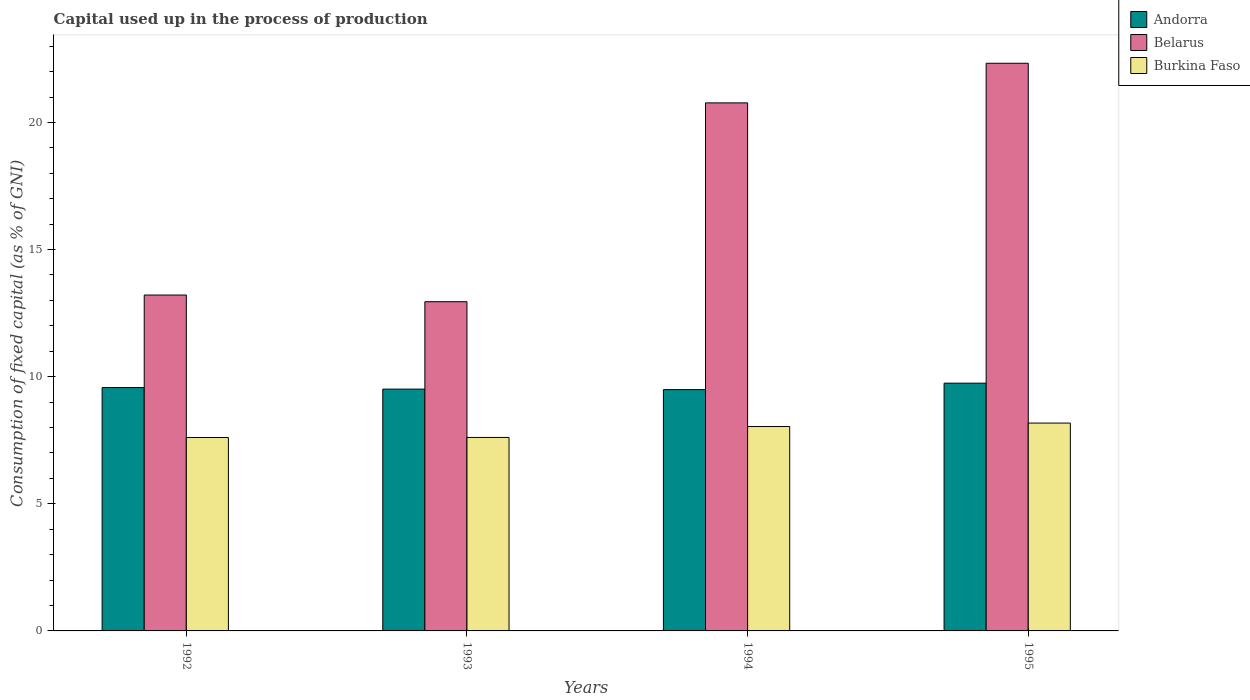Are the number of bars per tick equal to the number of legend labels?
Provide a succinct answer. Yes. Are the number of bars on each tick of the X-axis equal?
Ensure brevity in your answer.  Yes. How many bars are there on the 3rd tick from the right?
Offer a terse response. 3. What is the label of the 4th group of bars from the left?
Your answer should be very brief. 1995. In how many cases, is the number of bars for a given year not equal to the number of legend labels?
Make the answer very short. 0. What is the capital used up in the process of production in Belarus in 1995?
Provide a short and direct response. 22.33. Across all years, what is the maximum capital used up in the process of production in Belarus?
Give a very brief answer. 22.33. Across all years, what is the minimum capital used up in the process of production in Burkina Faso?
Keep it short and to the point. 7.61. In which year was the capital used up in the process of production in Burkina Faso minimum?
Ensure brevity in your answer.  1992. What is the total capital used up in the process of production in Belarus in the graph?
Provide a short and direct response. 69.26. What is the difference between the capital used up in the process of production in Andorra in 1992 and that in 1994?
Provide a succinct answer. 0.08. What is the difference between the capital used up in the process of production in Burkina Faso in 1992 and the capital used up in the process of production in Andorra in 1994?
Offer a very short reply. -1.88. What is the average capital used up in the process of production in Burkina Faso per year?
Ensure brevity in your answer.  7.86. In the year 1993, what is the difference between the capital used up in the process of production in Burkina Faso and capital used up in the process of production in Andorra?
Your answer should be very brief. -1.9. What is the ratio of the capital used up in the process of production in Burkina Faso in 1992 to that in 1994?
Make the answer very short. 0.95. What is the difference between the highest and the second highest capital used up in the process of production in Andorra?
Make the answer very short. 0.17. What is the difference between the highest and the lowest capital used up in the process of production in Belarus?
Ensure brevity in your answer.  9.38. In how many years, is the capital used up in the process of production in Burkina Faso greater than the average capital used up in the process of production in Burkina Faso taken over all years?
Give a very brief answer. 2. What does the 3rd bar from the left in 1994 represents?
Provide a short and direct response. Burkina Faso. What does the 3rd bar from the right in 1994 represents?
Offer a terse response. Andorra. Is it the case that in every year, the sum of the capital used up in the process of production in Belarus and capital used up in the process of production in Andorra is greater than the capital used up in the process of production in Burkina Faso?
Your answer should be very brief. Yes. How many bars are there?
Provide a short and direct response. 12. Are all the bars in the graph horizontal?
Your answer should be very brief. No. How many years are there in the graph?
Offer a very short reply. 4. What is the difference between two consecutive major ticks on the Y-axis?
Your response must be concise. 5. Does the graph contain any zero values?
Your answer should be compact. No. How many legend labels are there?
Your response must be concise. 3. What is the title of the graph?
Provide a short and direct response. Capital used up in the process of production. What is the label or title of the Y-axis?
Ensure brevity in your answer.  Consumption of fixed capital (as % of GNI). What is the Consumption of fixed capital (as % of GNI) of Andorra in 1992?
Your answer should be compact. 9.57. What is the Consumption of fixed capital (as % of GNI) of Belarus in 1992?
Provide a succinct answer. 13.21. What is the Consumption of fixed capital (as % of GNI) of Burkina Faso in 1992?
Offer a terse response. 7.61. What is the Consumption of fixed capital (as % of GNI) of Andorra in 1993?
Offer a very short reply. 9.51. What is the Consumption of fixed capital (as % of GNI) in Belarus in 1993?
Provide a short and direct response. 12.95. What is the Consumption of fixed capital (as % of GNI) in Burkina Faso in 1993?
Give a very brief answer. 7.61. What is the Consumption of fixed capital (as % of GNI) in Andorra in 1994?
Offer a terse response. 9.49. What is the Consumption of fixed capital (as % of GNI) of Belarus in 1994?
Provide a short and direct response. 20.77. What is the Consumption of fixed capital (as % of GNI) of Burkina Faso in 1994?
Your response must be concise. 8.04. What is the Consumption of fixed capital (as % of GNI) of Andorra in 1995?
Ensure brevity in your answer.  9.75. What is the Consumption of fixed capital (as % of GNI) in Belarus in 1995?
Provide a succinct answer. 22.33. What is the Consumption of fixed capital (as % of GNI) of Burkina Faso in 1995?
Give a very brief answer. 8.18. Across all years, what is the maximum Consumption of fixed capital (as % of GNI) in Andorra?
Your answer should be very brief. 9.75. Across all years, what is the maximum Consumption of fixed capital (as % of GNI) of Belarus?
Provide a short and direct response. 22.33. Across all years, what is the maximum Consumption of fixed capital (as % of GNI) in Burkina Faso?
Give a very brief answer. 8.18. Across all years, what is the minimum Consumption of fixed capital (as % of GNI) in Andorra?
Your answer should be very brief. 9.49. Across all years, what is the minimum Consumption of fixed capital (as % of GNI) in Belarus?
Offer a very short reply. 12.95. Across all years, what is the minimum Consumption of fixed capital (as % of GNI) of Burkina Faso?
Offer a very short reply. 7.61. What is the total Consumption of fixed capital (as % of GNI) in Andorra in the graph?
Ensure brevity in your answer.  38.32. What is the total Consumption of fixed capital (as % of GNI) in Belarus in the graph?
Provide a short and direct response. 69.26. What is the total Consumption of fixed capital (as % of GNI) in Burkina Faso in the graph?
Give a very brief answer. 31.43. What is the difference between the Consumption of fixed capital (as % of GNI) of Andorra in 1992 and that in 1993?
Provide a succinct answer. 0.06. What is the difference between the Consumption of fixed capital (as % of GNI) of Belarus in 1992 and that in 1993?
Your response must be concise. 0.26. What is the difference between the Consumption of fixed capital (as % of GNI) of Burkina Faso in 1992 and that in 1993?
Ensure brevity in your answer.  -0. What is the difference between the Consumption of fixed capital (as % of GNI) of Andorra in 1992 and that in 1994?
Offer a terse response. 0.08. What is the difference between the Consumption of fixed capital (as % of GNI) in Belarus in 1992 and that in 1994?
Offer a terse response. -7.56. What is the difference between the Consumption of fixed capital (as % of GNI) of Burkina Faso in 1992 and that in 1994?
Provide a short and direct response. -0.43. What is the difference between the Consumption of fixed capital (as % of GNI) of Andorra in 1992 and that in 1995?
Offer a very short reply. -0.17. What is the difference between the Consumption of fixed capital (as % of GNI) of Belarus in 1992 and that in 1995?
Offer a very short reply. -9.12. What is the difference between the Consumption of fixed capital (as % of GNI) of Burkina Faso in 1992 and that in 1995?
Your answer should be compact. -0.57. What is the difference between the Consumption of fixed capital (as % of GNI) of Andorra in 1993 and that in 1994?
Your response must be concise. 0.02. What is the difference between the Consumption of fixed capital (as % of GNI) in Belarus in 1993 and that in 1994?
Give a very brief answer. -7.82. What is the difference between the Consumption of fixed capital (as % of GNI) in Burkina Faso in 1993 and that in 1994?
Offer a terse response. -0.43. What is the difference between the Consumption of fixed capital (as % of GNI) of Andorra in 1993 and that in 1995?
Keep it short and to the point. -0.23. What is the difference between the Consumption of fixed capital (as % of GNI) of Belarus in 1993 and that in 1995?
Offer a very short reply. -9.38. What is the difference between the Consumption of fixed capital (as % of GNI) of Burkina Faso in 1993 and that in 1995?
Provide a short and direct response. -0.57. What is the difference between the Consumption of fixed capital (as % of GNI) of Andorra in 1994 and that in 1995?
Your response must be concise. -0.25. What is the difference between the Consumption of fixed capital (as % of GNI) of Belarus in 1994 and that in 1995?
Make the answer very short. -1.56. What is the difference between the Consumption of fixed capital (as % of GNI) in Burkina Faso in 1994 and that in 1995?
Provide a succinct answer. -0.14. What is the difference between the Consumption of fixed capital (as % of GNI) of Andorra in 1992 and the Consumption of fixed capital (as % of GNI) of Belarus in 1993?
Provide a succinct answer. -3.38. What is the difference between the Consumption of fixed capital (as % of GNI) of Andorra in 1992 and the Consumption of fixed capital (as % of GNI) of Burkina Faso in 1993?
Offer a terse response. 1.96. What is the difference between the Consumption of fixed capital (as % of GNI) in Belarus in 1992 and the Consumption of fixed capital (as % of GNI) in Burkina Faso in 1993?
Give a very brief answer. 5.6. What is the difference between the Consumption of fixed capital (as % of GNI) in Andorra in 1992 and the Consumption of fixed capital (as % of GNI) in Belarus in 1994?
Your answer should be very brief. -11.2. What is the difference between the Consumption of fixed capital (as % of GNI) of Andorra in 1992 and the Consumption of fixed capital (as % of GNI) of Burkina Faso in 1994?
Provide a short and direct response. 1.53. What is the difference between the Consumption of fixed capital (as % of GNI) of Belarus in 1992 and the Consumption of fixed capital (as % of GNI) of Burkina Faso in 1994?
Provide a short and direct response. 5.17. What is the difference between the Consumption of fixed capital (as % of GNI) in Andorra in 1992 and the Consumption of fixed capital (as % of GNI) in Belarus in 1995?
Ensure brevity in your answer.  -12.76. What is the difference between the Consumption of fixed capital (as % of GNI) of Andorra in 1992 and the Consumption of fixed capital (as % of GNI) of Burkina Faso in 1995?
Your answer should be very brief. 1.4. What is the difference between the Consumption of fixed capital (as % of GNI) of Belarus in 1992 and the Consumption of fixed capital (as % of GNI) of Burkina Faso in 1995?
Provide a succinct answer. 5.04. What is the difference between the Consumption of fixed capital (as % of GNI) in Andorra in 1993 and the Consumption of fixed capital (as % of GNI) in Belarus in 1994?
Make the answer very short. -11.26. What is the difference between the Consumption of fixed capital (as % of GNI) in Andorra in 1993 and the Consumption of fixed capital (as % of GNI) in Burkina Faso in 1994?
Give a very brief answer. 1.47. What is the difference between the Consumption of fixed capital (as % of GNI) in Belarus in 1993 and the Consumption of fixed capital (as % of GNI) in Burkina Faso in 1994?
Your answer should be compact. 4.91. What is the difference between the Consumption of fixed capital (as % of GNI) of Andorra in 1993 and the Consumption of fixed capital (as % of GNI) of Belarus in 1995?
Make the answer very short. -12.82. What is the difference between the Consumption of fixed capital (as % of GNI) in Andorra in 1993 and the Consumption of fixed capital (as % of GNI) in Burkina Faso in 1995?
Offer a very short reply. 1.34. What is the difference between the Consumption of fixed capital (as % of GNI) in Belarus in 1993 and the Consumption of fixed capital (as % of GNI) in Burkina Faso in 1995?
Give a very brief answer. 4.77. What is the difference between the Consumption of fixed capital (as % of GNI) in Andorra in 1994 and the Consumption of fixed capital (as % of GNI) in Belarus in 1995?
Your answer should be compact. -12.84. What is the difference between the Consumption of fixed capital (as % of GNI) of Andorra in 1994 and the Consumption of fixed capital (as % of GNI) of Burkina Faso in 1995?
Ensure brevity in your answer.  1.32. What is the difference between the Consumption of fixed capital (as % of GNI) in Belarus in 1994 and the Consumption of fixed capital (as % of GNI) in Burkina Faso in 1995?
Your response must be concise. 12.59. What is the average Consumption of fixed capital (as % of GNI) of Andorra per year?
Offer a terse response. 9.58. What is the average Consumption of fixed capital (as % of GNI) of Belarus per year?
Your response must be concise. 17.31. What is the average Consumption of fixed capital (as % of GNI) of Burkina Faso per year?
Offer a very short reply. 7.86. In the year 1992, what is the difference between the Consumption of fixed capital (as % of GNI) in Andorra and Consumption of fixed capital (as % of GNI) in Belarus?
Keep it short and to the point. -3.64. In the year 1992, what is the difference between the Consumption of fixed capital (as % of GNI) of Andorra and Consumption of fixed capital (as % of GNI) of Burkina Faso?
Keep it short and to the point. 1.97. In the year 1992, what is the difference between the Consumption of fixed capital (as % of GNI) of Belarus and Consumption of fixed capital (as % of GNI) of Burkina Faso?
Provide a short and direct response. 5.61. In the year 1993, what is the difference between the Consumption of fixed capital (as % of GNI) in Andorra and Consumption of fixed capital (as % of GNI) in Belarus?
Keep it short and to the point. -3.44. In the year 1993, what is the difference between the Consumption of fixed capital (as % of GNI) in Andorra and Consumption of fixed capital (as % of GNI) in Burkina Faso?
Ensure brevity in your answer.  1.9. In the year 1993, what is the difference between the Consumption of fixed capital (as % of GNI) of Belarus and Consumption of fixed capital (as % of GNI) of Burkina Faso?
Offer a terse response. 5.34. In the year 1994, what is the difference between the Consumption of fixed capital (as % of GNI) of Andorra and Consumption of fixed capital (as % of GNI) of Belarus?
Keep it short and to the point. -11.28. In the year 1994, what is the difference between the Consumption of fixed capital (as % of GNI) in Andorra and Consumption of fixed capital (as % of GNI) in Burkina Faso?
Provide a short and direct response. 1.45. In the year 1994, what is the difference between the Consumption of fixed capital (as % of GNI) of Belarus and Consumption of fixed capital (as % of GNI) of Burkina Faso?
Your answer should be compact. 12.73. In the year 1995, what is the difference between the Consumption of fixed capital (as % of GNI) of Andorra and Consumption of fixed capital (as % of GNI) of Belarus?
Offer a terse response. -12.58. In the year 1995, what is the difference between the Consumption of fixed capital (as % of GNI) of Andorra and Consumption of fixed capital (as % of GNI) of Burkina Faso?
Offer a terse response. 1.57. In the year 1995, what is the difference between the Consumption of fixed capital (as % of GNI) of Belarus and Consumption of fixed capital (as % of GNI) of Burkina Faso?
Your answer should be compact. 14.15. What is the ratio of the Consumption of fixed capital (as % of GNI) in Belarus in 1992 to that in 1993?
Give a very brief answer. 1.02. What is the ratio of the Consumption of fixed capital (as % of GNI) of Burkina Faso in 1992 to that in 1993?
Provide a short and direct response. 1. What is the ratio of the Consumption of fixed capital (as % of GNI) of Andorra in 1992 to that in 1994?
Offer a terse response. 1.01. What is the ratio of the Consumption of fixed capital (as % of GNI) of Belarus in 1992 to that in 1994?
Your response must be concise. 0.64. What is the ratio of the Consumption of fixed capital (as % of GNI) in Burkina Faso in 1992 to that in 1994?
Provide a succinct answer. 0.95. What is the ratio of the Consumption of fixed capital (as % of GNI) in Andorra in 1992 to that in 1995?
Offer a terse response. 0.98. What is the ratio of the Consumption of fixed capital (as % of GNI) in Belarus in 1992 to that in 1995?
Give a very brief answer. 0.59. What is the ratio of the Consumption of fixed capital (as % of GNI) of Burkina Faso in 1992 to that in 1995?
Your answer should be compact. 0.93. What is the ratio of the Consumption of fixed capital (as % of GNI) of Andorra in 1993 to that in 1994?
Make the answer very short. 1. What is the ratio of the Consumption of fixed capital (as % of GNI) of Belarus in 1993 to that in 1994?
Provide a short and direct response. 0.62. What is the ratio of the Consumption of fixed capital (as % of GNI) in Burkina Faso in 1993 to that in 1994?
Provide a succinct answer. 0.95. What is the ratio of the Consumption of fixed capital (as % of GNI) of Andorra in 1993 to that in 1995?
Offer a very short reply. 0.98. What is the ratio of the Consumption of fixed capital (as % of GNI) in Belarus in 1993 to that in 1995?
Provide a short and direct response. 0.58. What is the ratio of the Consumption of fixed capital (as % of GNI) of Burkina Faso in 1993 to that in 1995?
Provide a succinct answer. 0.93. What is the ratio of the Consumption of fixed capital (as % of GNI) in Belarus in 1994 to that in 1995?
Offer a very short reply. 0.93. What is the ratio of the Consumption of fixed capital (as % of GNI) in Burkina Faso in 1994 to that in 1995?
Make the answer very short. 0.98. What is the difference between the highest and the second highest Consumption of fixed capital (as % of GNI) in Andorra?
Your response must be concise. 0.17. What is the difference between the highest and the second highest Consumption of fixed capital (as % of GNI) of Belarus?
Provide a short and direct response. 1.56. What is the difference between the highest and the second highest Consumption of fixed capital (as % of GNI) of Burkina Faso?
Your answer should be very brief. 0.14. What is the difference between the highest and the lowest Consumption of fixed capital (as % of GNI) in Andorra?
Give a very brief answer. 0.25. What is the difference between the highest and the lowest Consumption of fixed capital (as % of GNI) of Belarus?
Provide a short and direct response. 9.38. What is the difference between the highest and the lowest Consumption of fixed capital (as % of GNI) in Burkina Faso?
Your response must be concise. 0.57. 